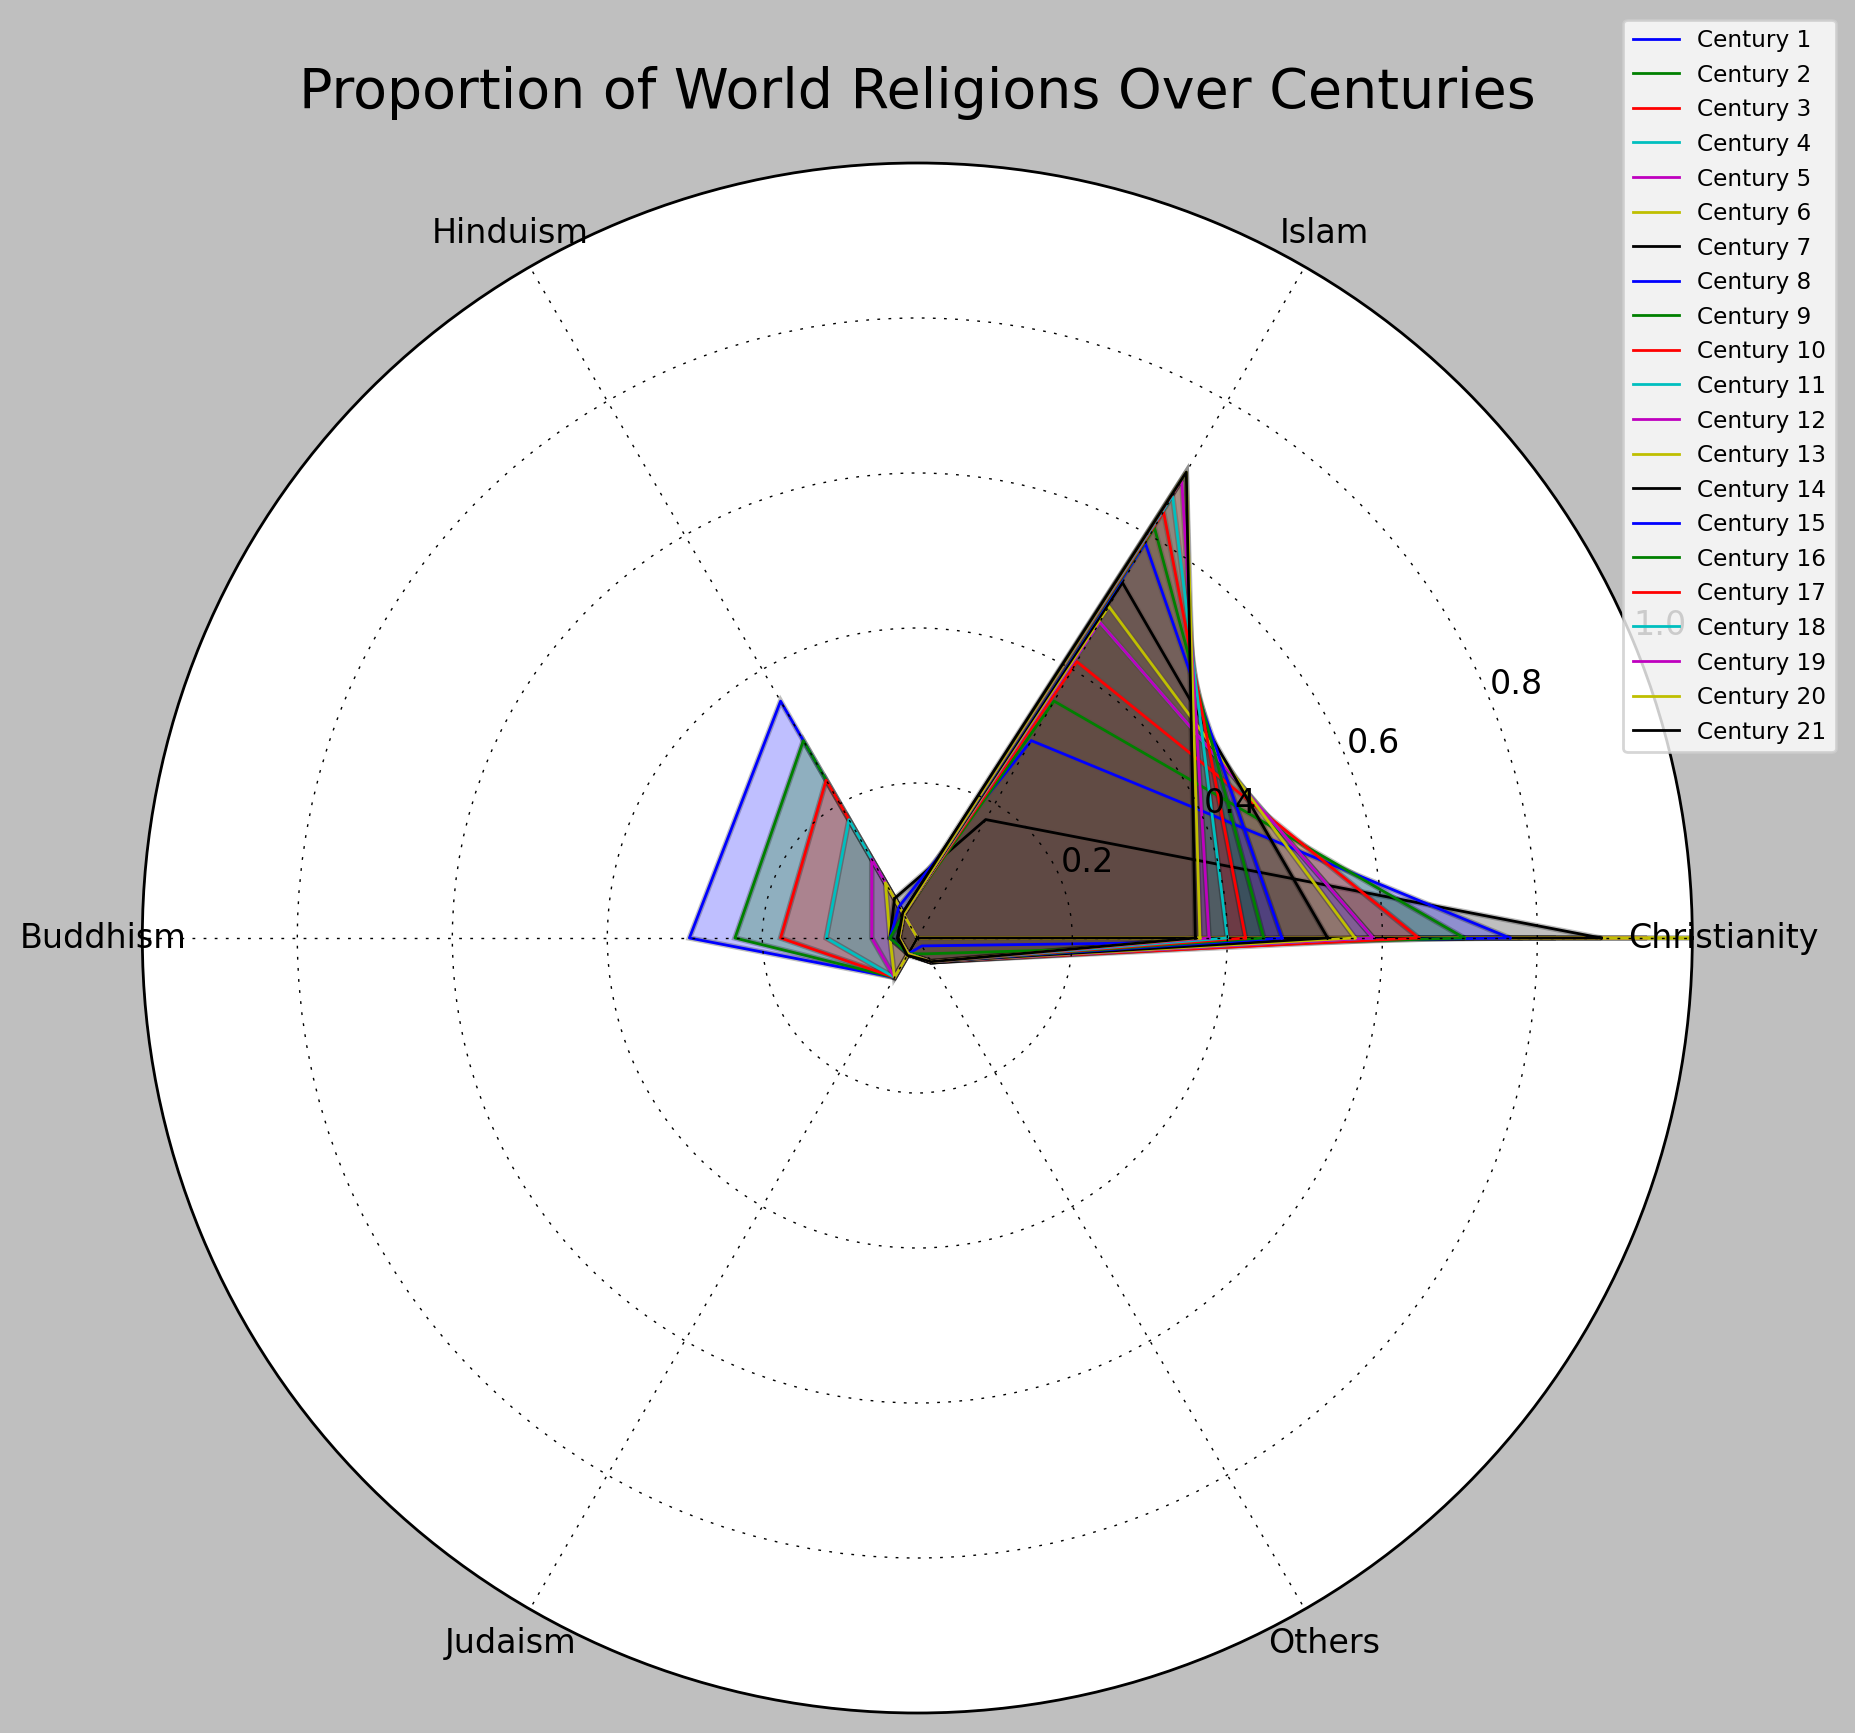What is the overall trend of Christianity's proportion from the 1st to the 21st century? Looking at the rose chart, the proportion of Christianity increases from the 1st century up to the 6th century and then gradually decreases afterward. The trend shows an initial rise followed by a steady decline.
Answer: Initial rise, then steady decline Between the 7th and the 14th centuries, which religion shows a consistent increase in proportion? By examining the rose chart, Islam is the religion that shows a consistent increase from the 7th to the 14th centuries.
Answer: Islam Which century had the highest proportion of Hinduism? From the figure, the highest proportion of Hinduism is in the 1st century.
Answer: 1st century How does the proportion of Buddhism compare between the 1st and the 21st centuries? Visually, Buddhism's proportion is consistently low from the 1st to the 21st centuries, showing a slight overall decrease. For instance, from 25% in the 1st century to 2.1% in the 21st century.
Answer: Decrease What can be inferred about the trend of Judaism's proportion over time? From the chart, Judaism's proportion is relatively stable, starting from 5% in the 1st century and maintaining around 2% to 3% from the 7th century onward.
Answer: Relatively stable Compare the proportions of Christianity and Islam in the 20th century. In the 20th century, Christianity accounts for approximately 31%, whereas Islam has a higher proportion of about 59%.
Answer: Islam has a higher proportion Which religion shows the most gradual change in proportion over the centuries? Hinduism has the most gradual change in its proportion as it starts around 30% and slowly converges to about 3%, without dramatic fluctuations.
Answer: Hinduism By the 15th century, how much has Christianity's proportion decreased from the 5th century? Christianity's proportion was 80% in the 5th century and decreased to 40% in the 15th century. The difference is 80% - 40% = 40%.
Answer: 40% What is the combined proportion of the "Others" category in the 21st century? As given in the data, the "Others" category has a proportion of 3% in the 21st century.
Answer: 3% During which centuries do Christianity and Islam have exactly opposite trends in the rose chart? The centuries where Christianity decreases while Islam increases are from the 7th to the 14th centuries.
Answer: 7th to 14th centuries 